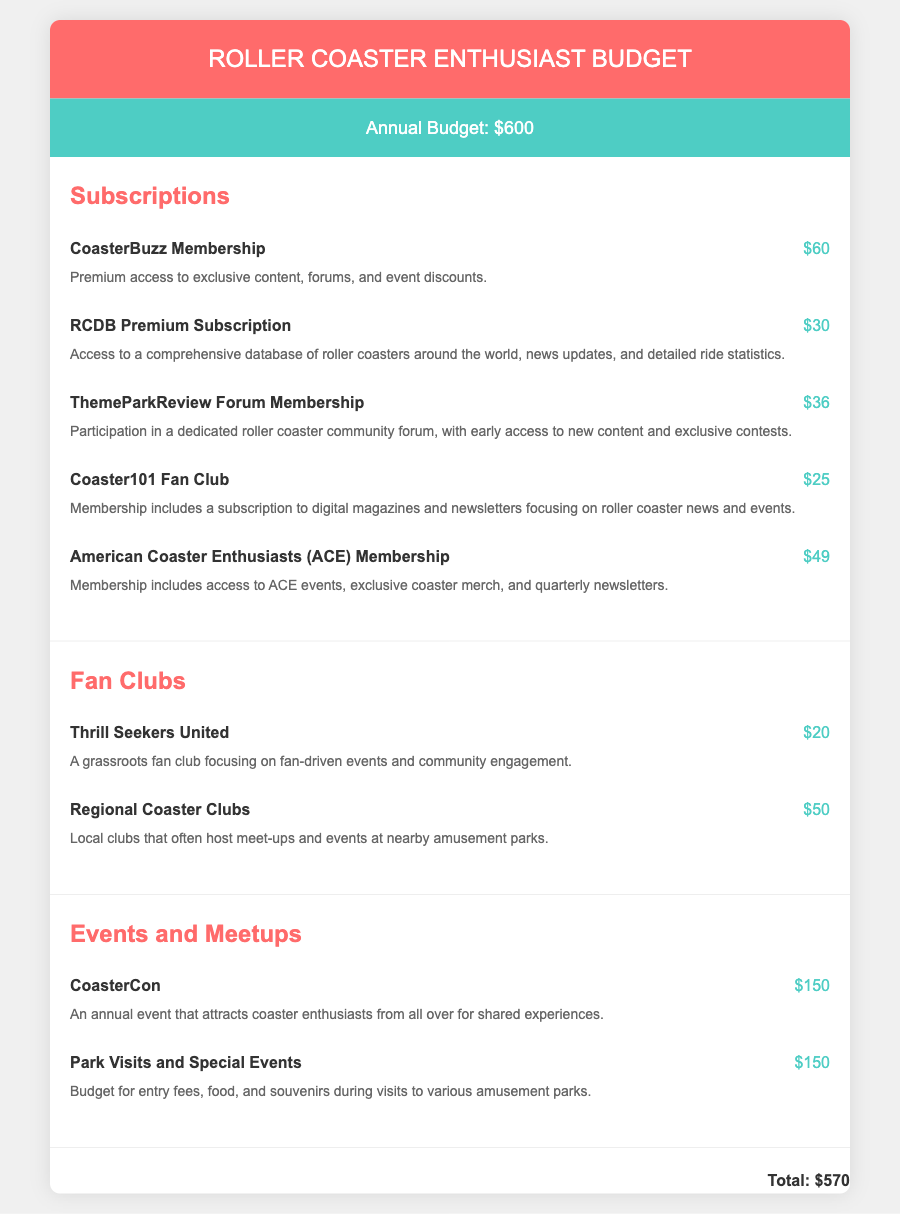What is the annual budget? The annual budget is stated at the top of the document, which indicates $600 for the roller coaster enthusiast budget.
Answer: $600 How much does an ACE Membership cost? The ACE Membership cost is listed under the subscriptions section. It shows $49 as the cost.
Answer: $49 What is the cost of CoasterCon? CoasterCon's cost is mentioned in the events and meetups section, which lists it as $150.
Answer: $150 Which fan club focuses on grassroots events? The fan club that focuses on grassroots events is Thrill Seekers United, as mentioned in the fan clubs section.
Answer: Thrill Seekers United How much is the total for all subscriptions? The total for all subscriptions is not explicitly stated, but it can be reasoned by adding the individual costs found in the subscriptions section.
Answer: $200 What is included in the Coaster101 Fan Club membership? The Coaster101 Fan Club membership includes a subscription to digital magazines and newsletters, as described in its item description.
Answer: Digital magazines and newsletters What type of content does the RCDB Premium Subscription provide access to? The RCDB Premium Subscription provides access to a comprehensive database of roller coasters, news updates, and ride statistics. This information is provided in its description.
Answer: Comprehensive database of roller coasters How many events and meetups are listed in the document? The document lists two events and meetups: CoasterCon and Park Visits and Special Events, making it easy to count them.
Answer: 2 